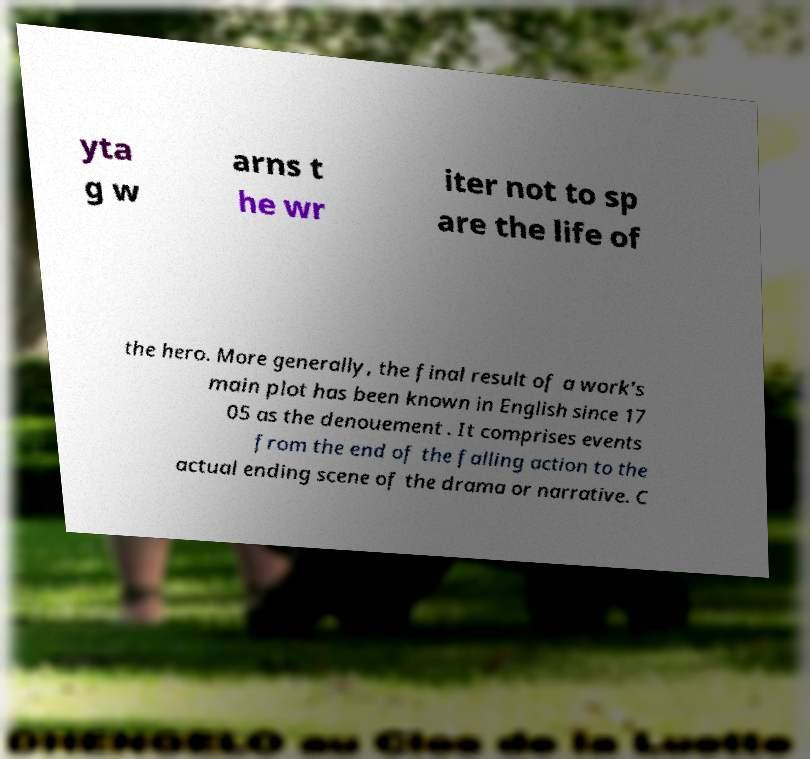Could you assist in decoding the text presented in this image and type it out clearly? yta g w arns t he wr iter not to sp are the life of the hero. More generally, the final result of a work's main plot has been known in English since 17 05 as the denouement . It comprises events from the end of the falling action to the actual ending scene of the drama or narrative. C 